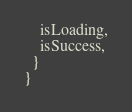Convert code to text. <code><loc_0><loc_0><loc_500><loc_500><_TypeScript_>    isLoading,
    isSuccess,
  }
}
</code> 